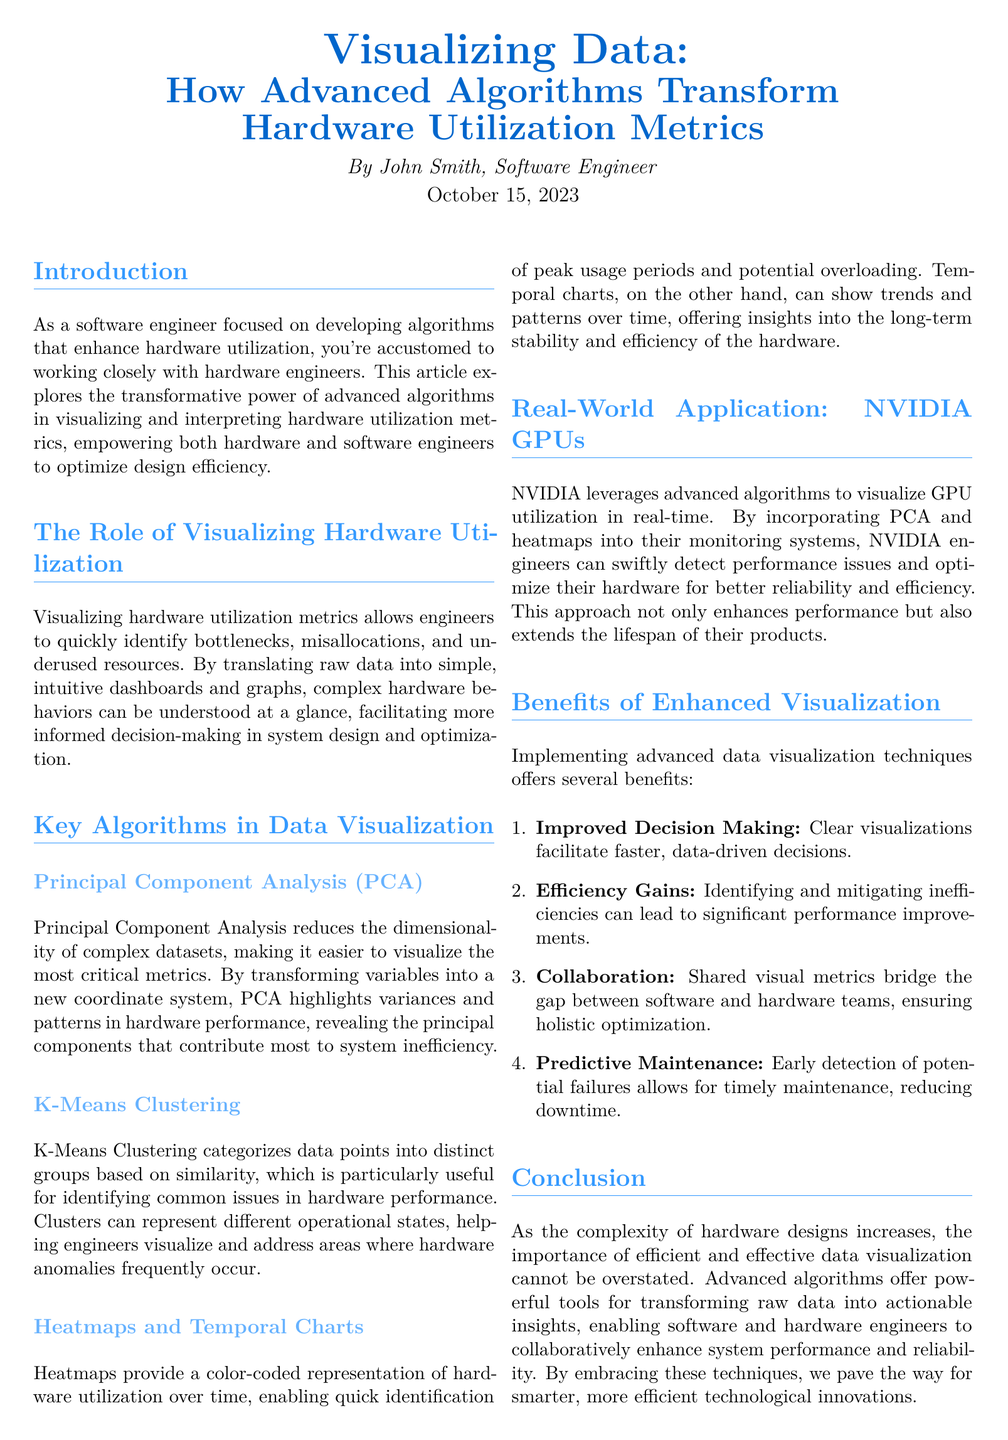What is the title of the article? The title of the article is presented at the top and is "Visualizing Data: How Advanced Algorithms Transform Hardware Utilization Metrics."
Answer: Visualizing Data: How Advanced Algorithms Transform Hardware Utilization Metrics Who is the author of the article? The author is mentioned beneath the title, and the name is John Smith.
Answer: John Smith What date was the article published? The publication date is specified in the document as October 15, 2023.
Answer: October 15, 2023 What is the first key algorithm discussed in the article? The first key algorithm mentioned in the article is Principal Component Analysis, indicated in the section on algorithms.
Answer: Principal Component Analysis What type of visualization does NVIDIA utilize for GPU performance? The document states that NVIDIA utilizes heatmaps for visualizing GPU utilization.
Answer: heatmaps How does visualizing hardware utilization help engineers? The document suggests that visualizing hardware metrics helps identify bottlenecks.
Answer: identify bottlenecks What benefit of enhanced visualization is mentioned in the document? One benefit highlighted in the article is improved decision making from clear visualizations.
Answer: Improved Decision Making What modeling technique categorizes data points in the document? K-Means Clustering is the technique identified in the document for categorizing data points based on similarity.
Answer: K-Means Clustering What percentage of the document's content focuses on algorithms? The document doesn't specify a percentage, but a significant part is dedicated to the section "Key Algorithms in Data Visualization."
Answer: significant part 